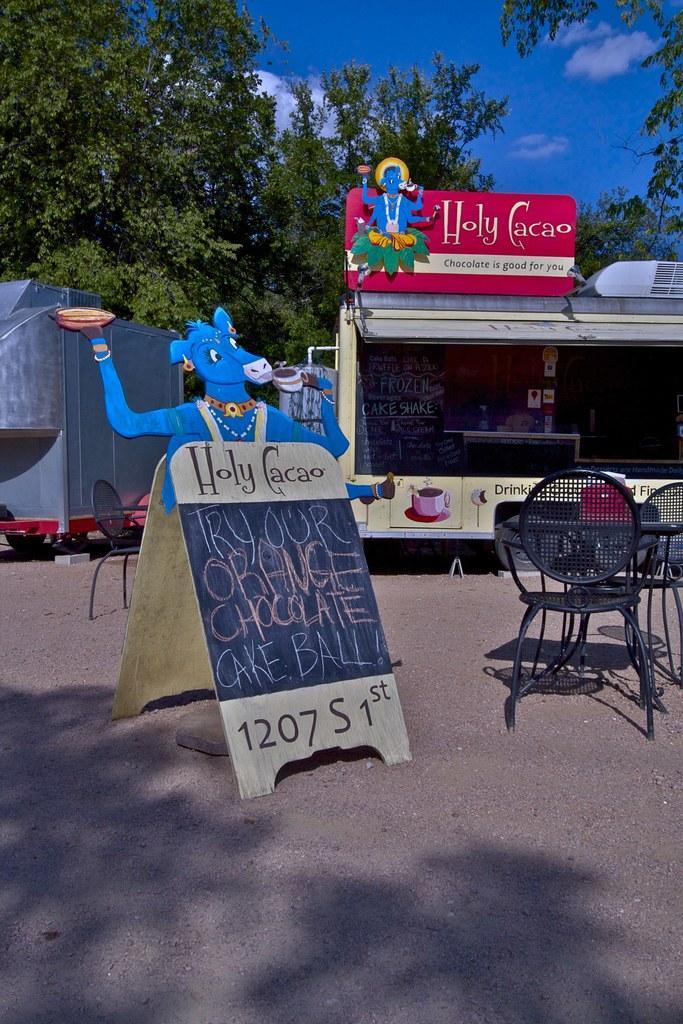Can you describe this image briefly? In this image there are chairs and a table, on a land and there is a board, on that board there is some text, in the background there is a shop, for that shop there are boards, on that board's there is some text and tree and the sky. 